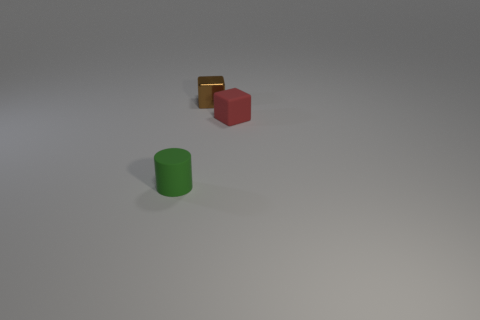Is there anything else that has the same material as the brown cube?
Offer a terse response. No. Is the small metallic thing the same color as the rubber block?
Make the answer very short. No. What is the shape of the small object that is made of the same material as the small green cylinder?
Make the answer very short. Cube. What number of small brown objects have the same shape as the red matte object?
Your answer should be compact. 1. What shape is the small matte object that is left of the small cube that is on the right side of the tiny brown thing?
Offer a terse response. Cylinder. Do the rubber object in front of the red object and the small shiny thing have the same size?
Your answer should be very brief. Yes. There is a object that is both left of the tiny matte block and in front of the tiny brown cube; what size is it?
Offer a very short reply. Small. How many rubber objects have the same size as the rubber cylinder?
Keep it short and to the point. 1. There is a rubber thing that is on the right side of the small green cylinder; how many rubber things are to the left of it?
Keep it short and to the point. 1. There is a block that is in front of the brown cube; is its color the same as the matte cylinder?
Provide a short and direct response. No. 